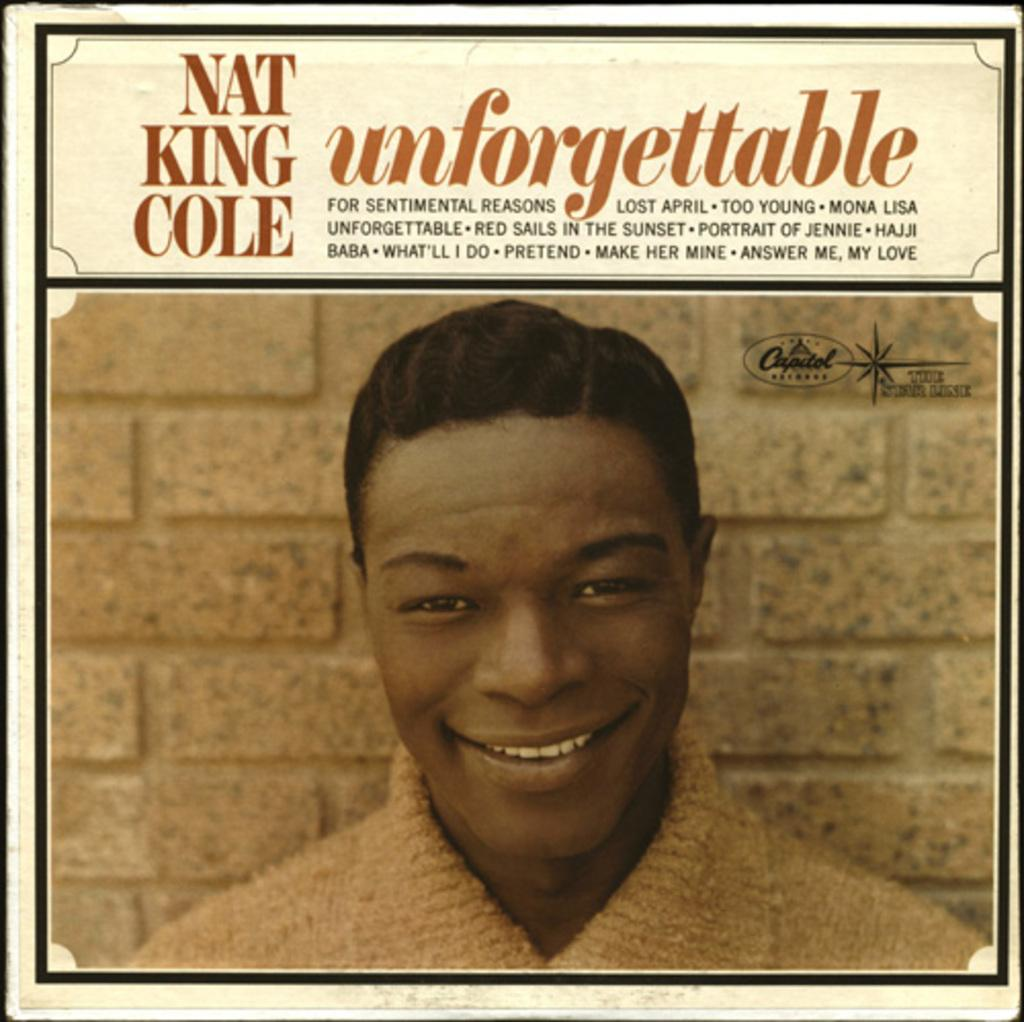What is the purpose of the image? The image is for a poster. What can be found at the top of the image? There is text at the top of the image. What is visible in the background of the image? There is a wall in the background of the image. Who is the main subject in the image? There is a man in the middle of the image. What is the man's facial expression? The man has a smiling face. Can you hear the toad croaking in the image? There is no toad present in the image, so it is not possible to hear any croaking. 